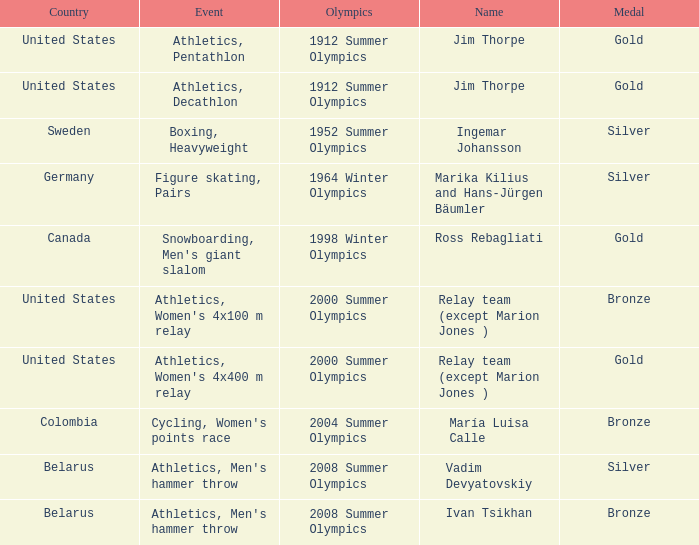Parse the full table. {'header': ['Country', 'Event', 'Olympics', 'Name', 'Medal'], 'rows': [['United States', 'Athletics, Pentathlon', '1912 Summer Olympics', 'Jim Thorpe', 'Gold'], ['United States', 'Athletics, Decathlon', '1912 Summer Olympics', 'Jim Thorpe', 'Gold'], ['Sweden', 'Boxing, Heavyweight', '1952 Summer Olympics', 'Ingemar Johansson', 'Silver'], ['Germany', 'Figure skating, Pairs', '1964 Winter Olympics', 'Marika Kilius and Hans-Jürgen Bäumler', 'Silver'], ['Canada', "Snowboarding, Men's giant slalom", '1998 Winter Olympics', 'Ross Rebagliati', 'Gold'], ['United States', "Athletics, Women's 4x100 m relay", '2000 Summer Olympics', 'Relay team (except Marion Jones )', 'Bronze'], ['United States', "Athletics, Women's 4x400 m relay", '2000 Summer Olympics', 'Relay team (except Marion Jones )', 'Gold'], ['Colombia', "Cycling, Women's points race", '2004 Summer Olympics', 'María Luisa Calle', 'Bronze'], ['Belarus', "Athletics, Men's hammer throw", '2008 Summer Olympics', 'Vadim Devyatovskiy', 'Silver'], ['Belarus', "Athletics, Men's hammer throw", '2008 Summer Olympics', 'Ivan Tsikhan', 'Bronze']]} What country has a silver medal in the boxing, heavyweight event? Sweden. 